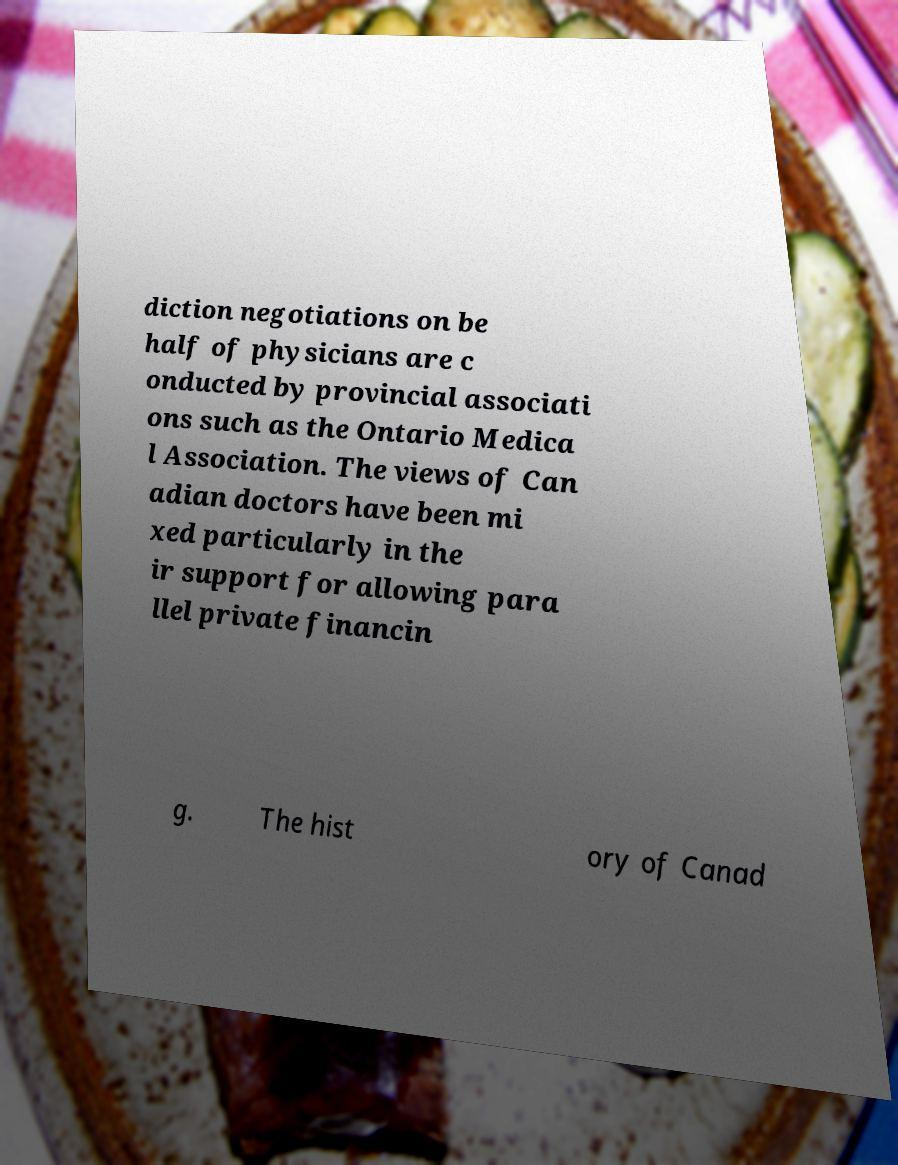Could you assist in decoding the text presented in this image and type it out clearly? diction negotiations on be half of physicians are c onducted by provincial associati ons such as the Ontario Medica l Association. The views of Can adian doctors have been mi xed particularly in the ir support for allowing para llel private financin g. The hist ory of Canad 